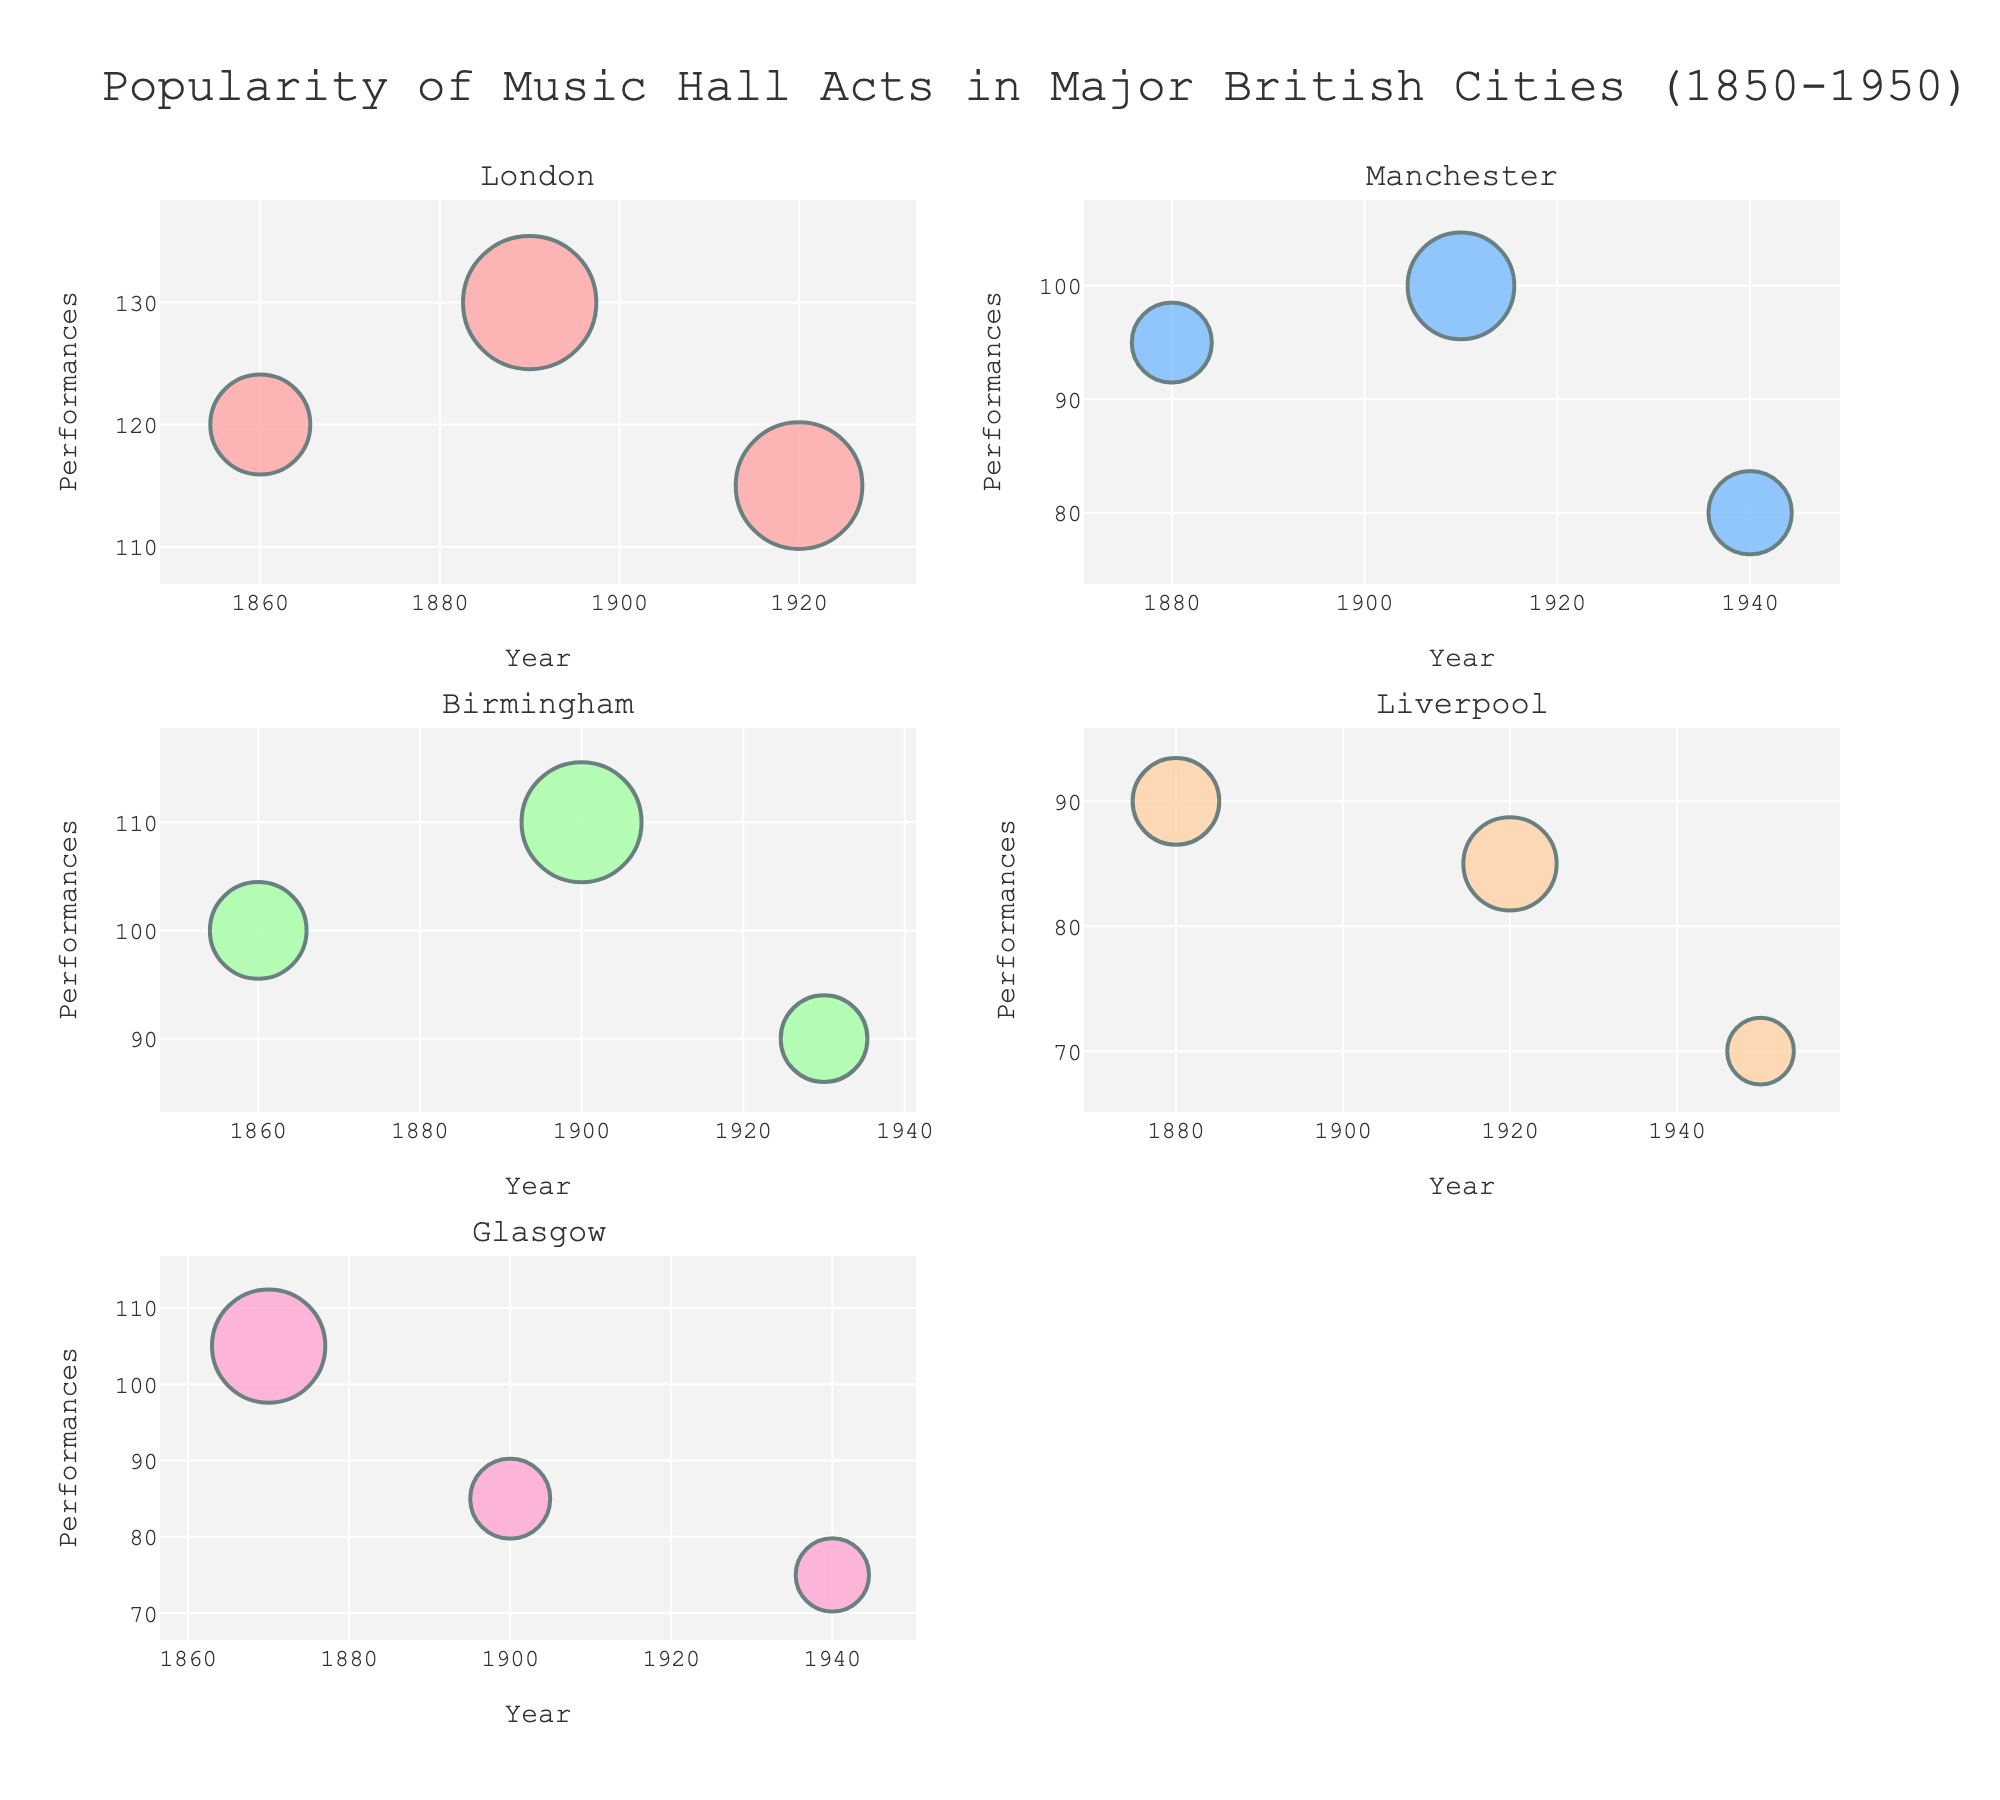What city has the act with the highest number of performances? To determine the city with the act that has the highest number of performances, we look at all the plots and identify the highest performance value. "Little Tich" in London in 1890 has 130 performances, which is the highest.
Answer: London Which act drew the largest audience size in Liverpool? To determine the act with the largest audience size in Liverpool, we focus on the bubble sizes in the Liverpool subplot. "Harry Lauder" in 1920 has the largest audience with 14,000 people.
Answer: Harry Lauder How many acts performed in Glasgow from 1850 to 1950? We need to count the number of data points (bubbles) in the Glasgow subplot. There are three acts: George Leybourne (1870), Harry Champion (1900), and Gracie Fields (1940).
Answer: 3 Between London and Manchester, which city had more performances in 1920? We look at the subplots for both London and Manchester and locate the data points for 1920. London had "Vesta Tilley" with 115 performances, while Manchester had no data point for 1920. Hence, London had more performances.
Answer: London What is the average audience size for acts that performed in Birmingham? We calculate the average by summing the audience sizes for Birmingham acts and dividing by the number of acts. The audience sizes are 14500, 18000, and 13000. Sum = 45500; number of acts = 3. Average = 45500 / 3 = 15167.
Answer: 15167 Which act in London had the second most performances? We look at the London subplot and identify the acts and their performances. "Little Tich" had the most with 130 performances, "Vesta Tilley" had 115 performances, and "The Great Vance" had 120 performances. Hence, "The Great Vance" had the second most performances.
Answer: The Great Vance What trend can be observed about the number of performances in Manchester from 1880 to 1940? Looking at the Manchester subplot, we observe when the points are plotted; there is a decreasing trend: 95 (1880), 100 (1910), and 80 (1940). This suggests a general decrease in performances over time.
Answer: Decreasing Which year had the highest total audience size across all cities? We need to find the sum of audience sizes across all cities for each year and identify the highest. Summing for each year and comparing gives the highest total audience size in 1920.
Answer: 1920 What is the difference in performances between the acts in Birmingham in 1860 and 1900? We look at the Birmingham subplot, identifying the performances for acts in 1860 and 1900. Sam Cowell (1860) had 100 performances, and Dan Leno (1900) had 110 performances. The difference is 110 - 100 = 10.
Answer: 10 What is the largest bubble size (representing audience size) observed in the London subplot? In the London subplot, we identify the bubble with the largest size. "Little Tich" in 1890 has the largest audience size of 20,000.
Answer: 20,000 